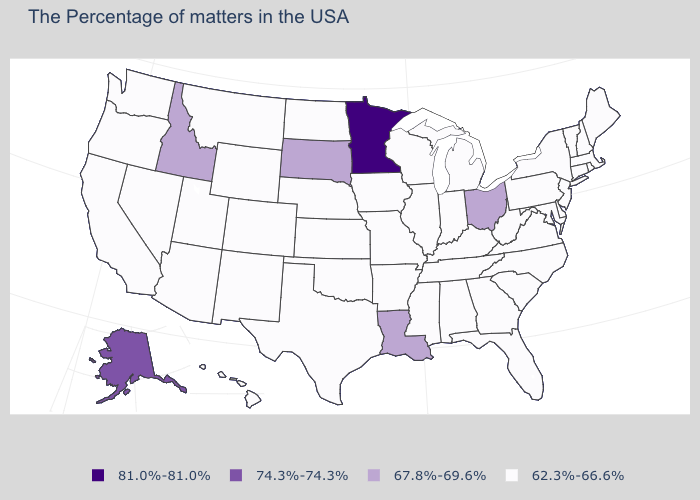Name the states that have a value in the range 67.8%-69.6%?
Quick response, please. Ohio, Louisiana, South Dakota, Idaho. What is the value of Michigan?
Short answer required. 62.3%-66.6%. What is the value of Connecticut?
Keep it brief. 62.3%-66.6%. Does Virginia have a lower value than Illinois?
Be succinct. No. Does Colorado have the highest value in the USA?
Answer briefly. No. Does Massachusetts have a higher value than Washington?
Short answer required. No. Which states have the highest value in the USA?
Be succinct. Minnesota. What is the value of West Virginia?
Keep it brief. 62.3%-66.6%. What is the value of North Carolina?
Keep it brief. 62.3%-66.6%. What is the lowest value in the MidWest?
Answer briefly. 62.3%-66.6%. Which states have the lowest value in the USA?
Write a very short answer. Maine, Massachusetts, Rhode Island, New Hampshire, Vermont, Connecticut, New York, New Jersey, Delaware, Maryland, Pennsylvania, Virginia, North Carolina, South Carolina, West Virginia, Florida, Georgia, Michigan, Kentucky, Indiana, Alabama, Tennessee, Wisconsin, Illinois, Mississippi, Missouri, Arkansas, Iowa, Kansas, Nebraska, Oklahoma, Texas, North Dakota, Wyoming, Colorado, New Mexico, Utah, Montana, Arizona, Nevada, California, Washington, Oregon, Hawaii. What is the value of New Hampshire?
Concise answer only. 62.3%-66.6%. Name the states that have a value in the range 67.8%-69.6%?
Be succinct. Ohio, Louisiana, South Dakota, Idaho. What is the value of Nebraska?
Be succinct. 62.3%-66.6%. 